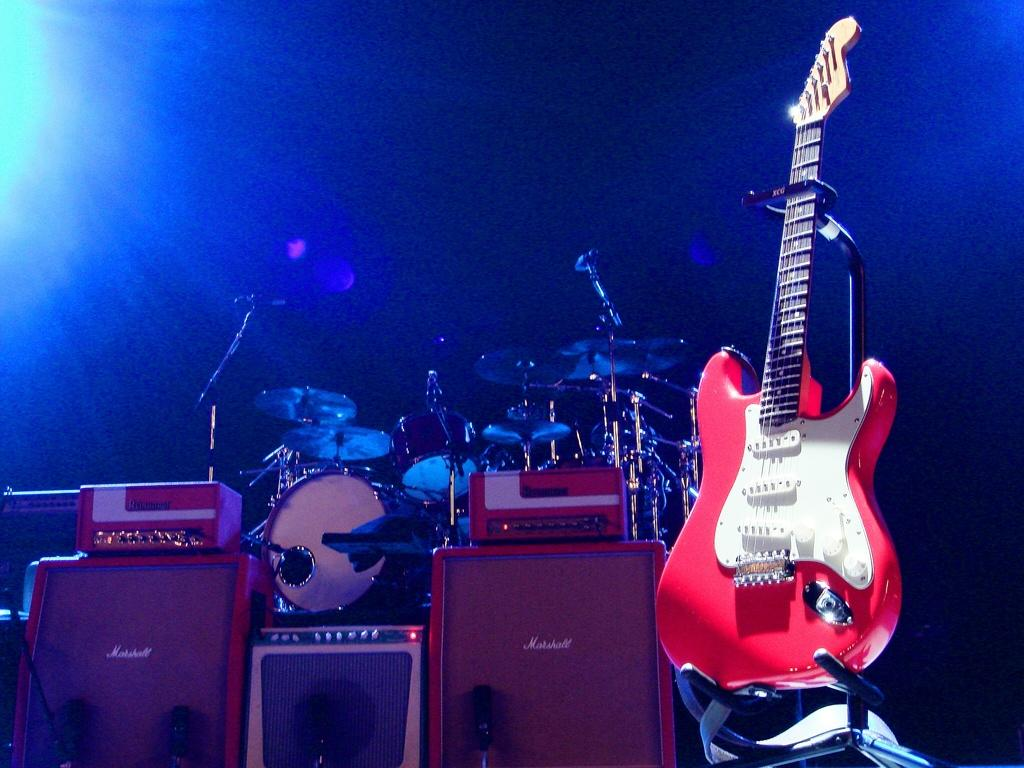What musical instrument can be seen in the image? There is a guitar in the image. What other musical instrument is present in the image? There are drums in the image. What type of equipment is visible in the image? There are equipment in the image. What color is the background of the image? The background of the image is blue. How many rabbits are present at the party in the image? There are no rabbits or party depicted in the image; it features musical instruments and equipment. 